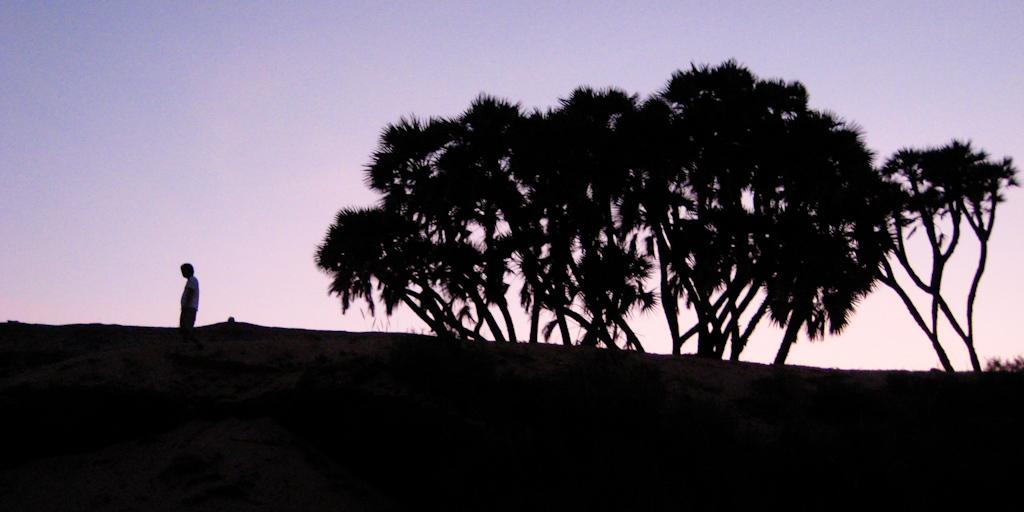What time of day is depicted in the image? The image is taken during the evening. What type of natural scenery can be seen in the image? There are trees in the image. Can you describe the presence of a human in the image? There is a person in the image. What is visible in the background of the image? The sky is visible in the image. What type of volleyball game is being played in the image? There is no volleyball game present in the image. Can you describe the girl in the image? There is no girl mentioned in the provided facts, so we cannot describe her. 